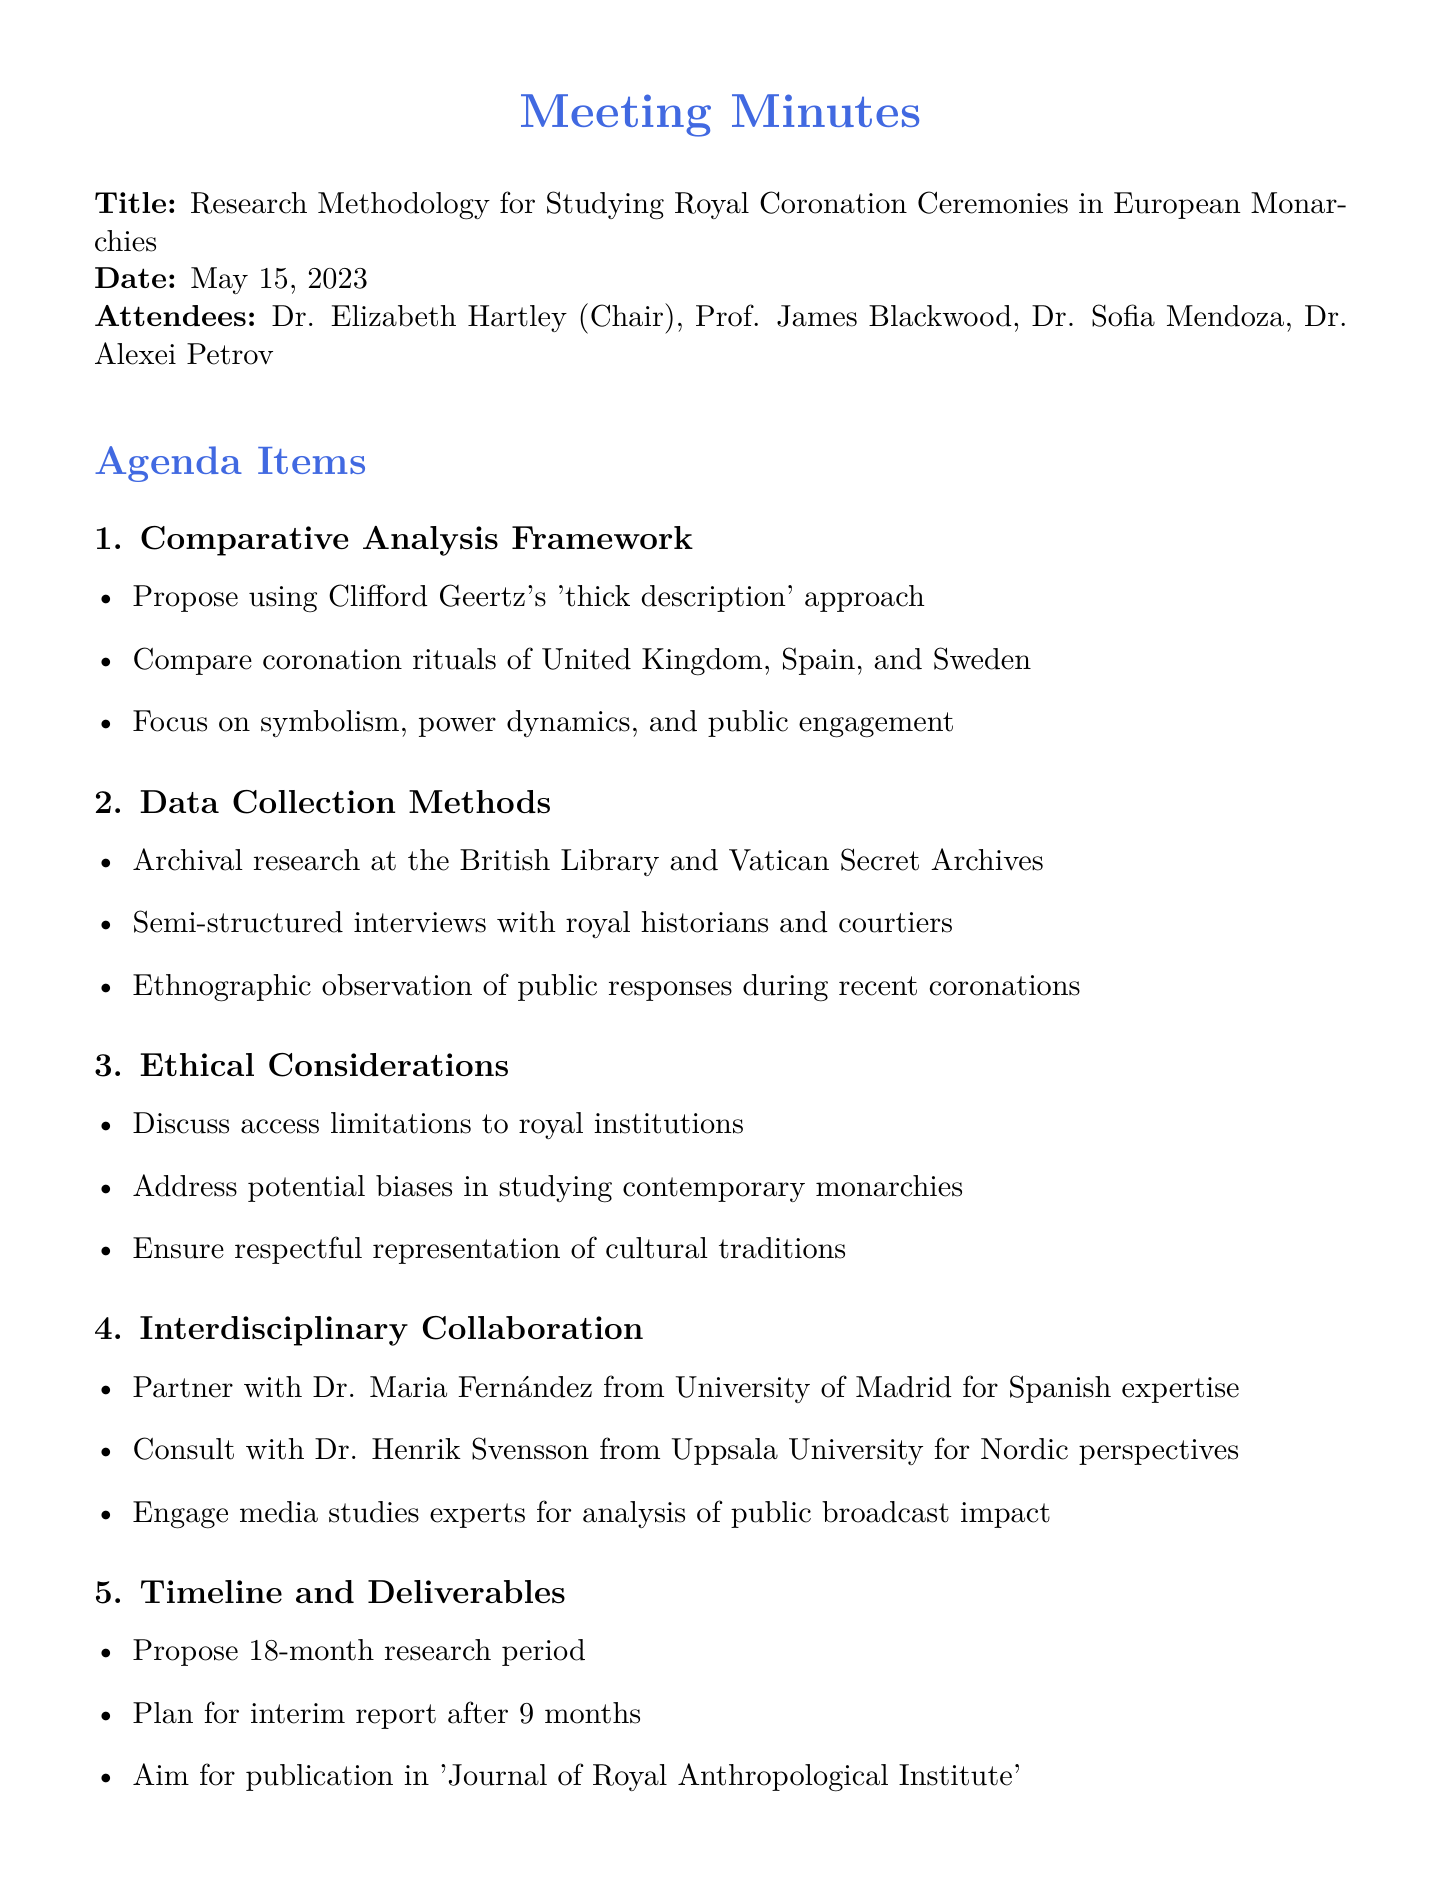What is the title of the meeting? The title is stated clearly at the beginning of the document.
Answer: Research Methodology for Studying Royal Coronation Ceremonies in European Monarchies Who chaired the meeting? The chairperson of the meeting is listed among the attendees.
Answer: Dr. Elizabeth Hartley What date was the meeting held? The date is explicitly mentioned in the document.
Answer: May 15, 2023 Which frameworks were proposed for the comparative analysis? The proposed frameworks are detailed in the agenda section regarding the comparative analysis.
Answer: Clifford Geertz's 'thick description' approach How long is the proposed research period? The timeline for the research period is mentioned in the timeline and deliverables section.
Answer: 18 months What type of research involves direct observation of public responses? This method is highlighted in the data collection methods section.
Answer: Ethnographic observation Who is responsible for drafting the research proposal? The action items list assigns this responsibility to a specific attendee.
Answer: Dr. Hartley Which journal aims to publish the research findings? The desired publication outlet is noted in the timeline and deliverables section.
Answer: Journal of Royal Anthropological Institute What is one ethical consideration mentioned? The document lists ethical considerations regarding the study of monarchies.
Answer: Access limitations to royal institutions 